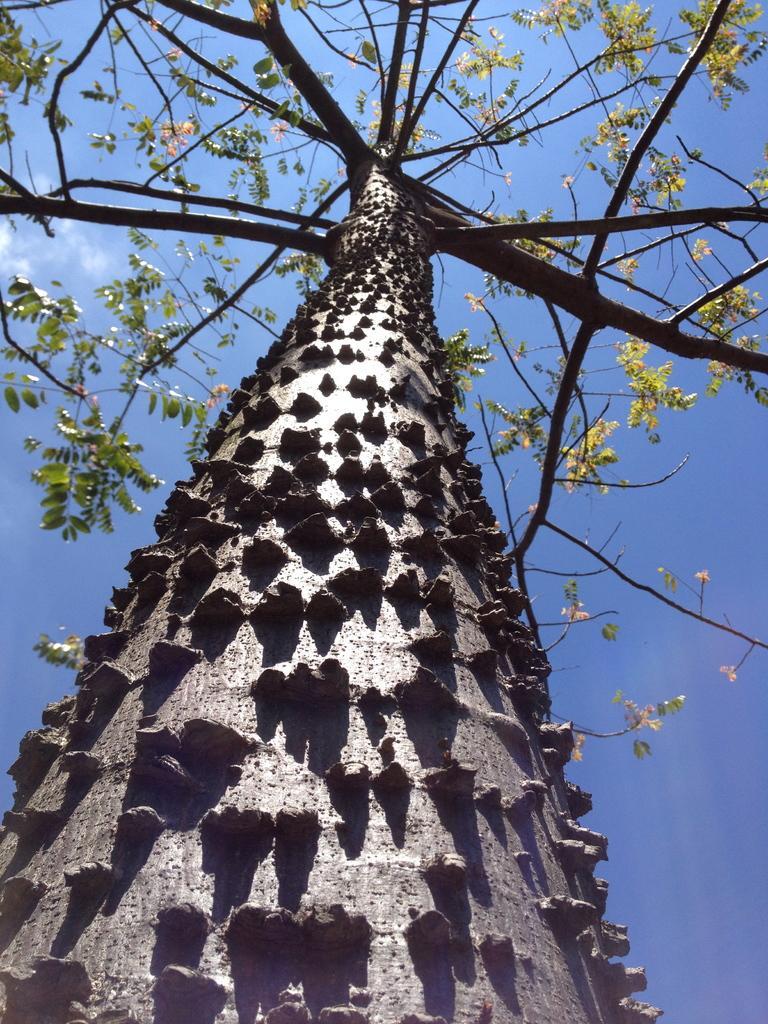Could you give a brief overview of what you see in this image? In this image I can see the tree in green color, background the sky is in blue and white color. 